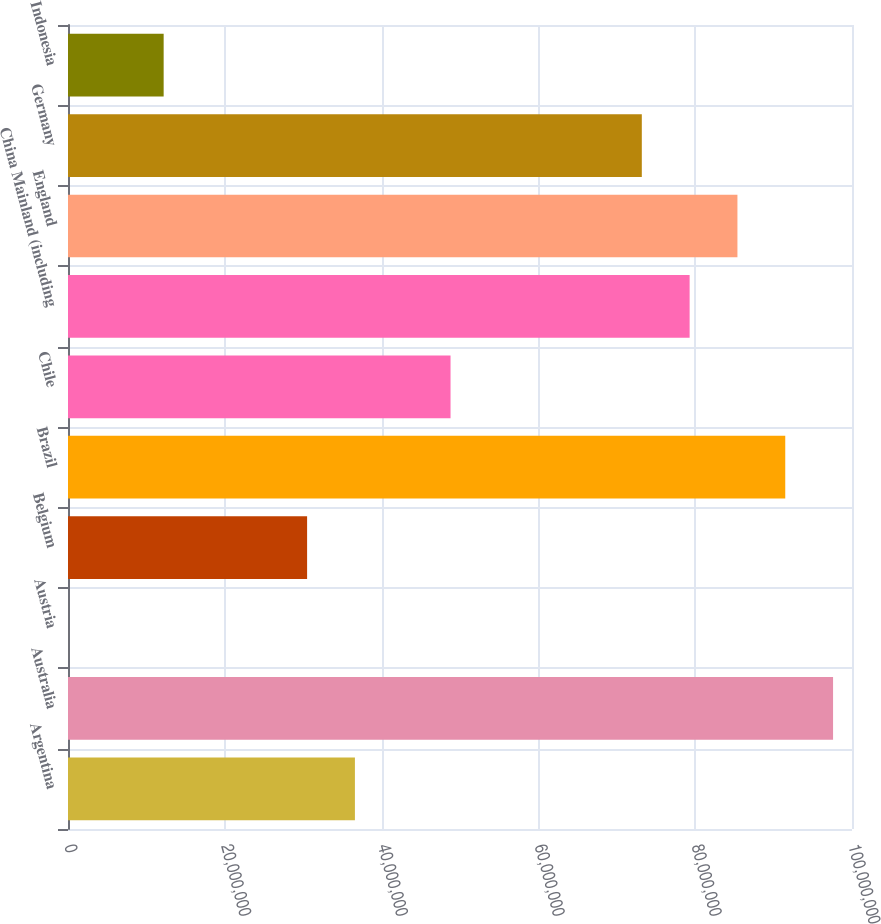<chart> <loc_0><loc_0><loc_500><loc_500><bar_chart><fcel>Argentina<fcel>Australia<fcel>Austria<fcel>Belgium<fcel>Brazil<fcel>Chile<fcel>China Mainland (including<fcel>England<fcel>Germany<fcel>Indonesia<nl><fcel>3.65965e+07<fcel>9.75851e+07<fcel>3300<fcel>3.04976e+07<fcel>9.14863e+07<fcel>4.87942e+07<fcel>7.92885e+07<fcel>8.53874e+07<fcel>7.31897e+07<fcel>1.2201e+07<nl></chart> 